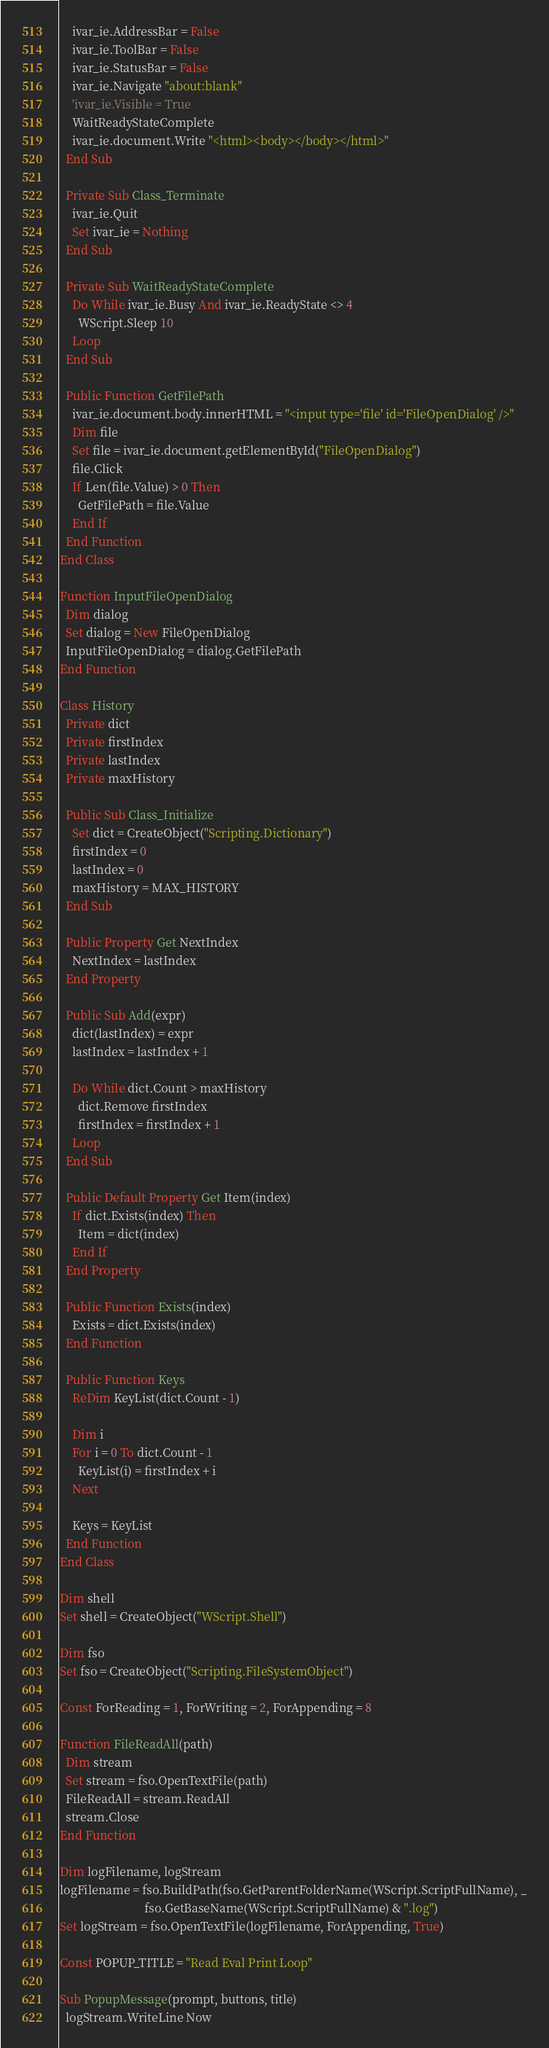<code> <loc_0><loc_0><loc_500><loc_500><_VisualBasic_>    ivar_ie.AddressBar = False
    ivar_ie.ToolBar = False
    ivar_ie.StatusBar = False
    ivar_ie.Navigate "about:blank"
    'ivar_ie.Visible = True
    WaitReadyStateComplete
    ivar_ie.document.Write "<html><body></body></html>"
  End Sub

  Private Sub Class_Terminate
    ivar_ie.Quit
    Set ivar_ie = Nothing
  End Sub

  Private Sub WaitReadyStateComplete
    Do While ivar_ie.Busy And ivar_ie.ReadyState <> 4
      WScript.Sleep 10
    Loop
  End Sub

  Public Function GetFilePath
    ivar_ie.document.body.innerHTML = "<input type='file' id='FileOpenDialog' />"
    Dim file
    Set file = ivar_ie.document.getElementById("FileOpenDialog")
    file.Click
    If Len(file.Value) > 0 Then
      GetFilePath = file.Value
    End If
  End Function
End Class

Function InputFileOpenDialog
  Dim dialog
  Set dialog = New FileOpenDialog
  InputFileOpenDialog = dialog.GetFilePath
End Function

Class History
  Private dict
  Private firstIndex
  Private lastIndex
  Private maxHistory

  Public Sub Class_Initialize
    Set dict = CreateObject("Scripting.Dictionary")
    firstIndex = 0
    lastIndex = 0
    maxHistory = MAX_HISTORY
  End Sub

  Public Property Get NextIndex
    NextIndex = lastIndex
  End Property

  Public Sub Add(expr)
    dict(lastIndex) = expr
    lastIndex = lastIndex + 1

    Do While dict.Count > maxHistory
      dict.Remove firstIndex
      firstIndex = firstIndex + 1
    Loop
  End Sub

  Public Default Property Get Item(index)
    If dict.Exists(index) Then
      Item = dict(index)
    End If
  End Property

  Public Function Exists(index)
    Exists = dict.Exists(index)
  End Function

  Public Function Keys
    ReDim KeyList(dict.Count - 1)

    Dim i
    For i = 0 To dict.Count - 1
      KeyList(i) = firstIndex + i
    Next

    Keys = KeyList
  End Function
End Class

Dim shell
Set shell = CreateObject("WScript.Shell")

Dim fso
Set fso = CreateObject("Scripting.FileSystemObject")

Const ForReading = 1, ForWriting = 2, ForAppending = 8

Function FileReadAll(path)
  Dim stream
  Set stream = fso.OpenTextFile(path)
  FileReadAll = stream.ReadAll
  stream.Close
End Function

Dim logFilename, logStream
logFilename = fso.BuildPath(fso.GetParentFolderName(WScript.ScriptFullName), _
                            fso.GetBaseName(WScript.ScriptFullName) & ".log")
Set logStream = fso.OpenTextFile(logFilename, ForAppending, True)

Const POPUP_TITLE = "Read Eval Print Loop"

Sub PopupMessage(prompt, buttons, title)
  logStream.WriteLine Now</code> 